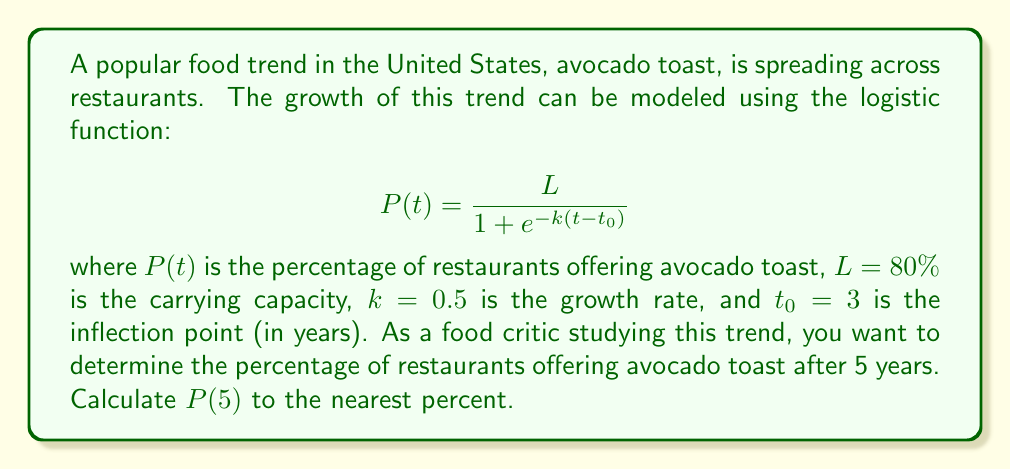What is the answer to this math problem? To solve this problem, we'll follow these steps:

1) We are given the logistic function:
   $$P(t) = \frac{L}{1 + e^{-k(t-t_0)}}$$

2) We know the following parameters:
   $L = 80\%$ (carrying capacity)
   $k = 0.5$ (growth rate)
   $t_0 = 3$ (inflection point)
   $t = 5$ (time we're interested in)

3) Let's substitute these values into the equation:
   $$P(5) = \frac{80}{1 + e^{-0.5(5-3)}}$$

4) Simplify the exponent:
   $$P(5) = \frac{80}{1 + e^{-0.5(2)}} = \frac{80}{1 + e^{-1}}$$

5) Calculate $e^{-1}$:
   $$P(5) = \frac{80}{1 + 0.3679}$$

6) Add the denominator:
   $$P(5) = \frac{80}{1.3679}$$

7) Divide:
   $$P(5) = 58.4838...$$

8) Rounding to the nearest percent:
   $$P(5) \approx 58\%$$
Answer: 58% 